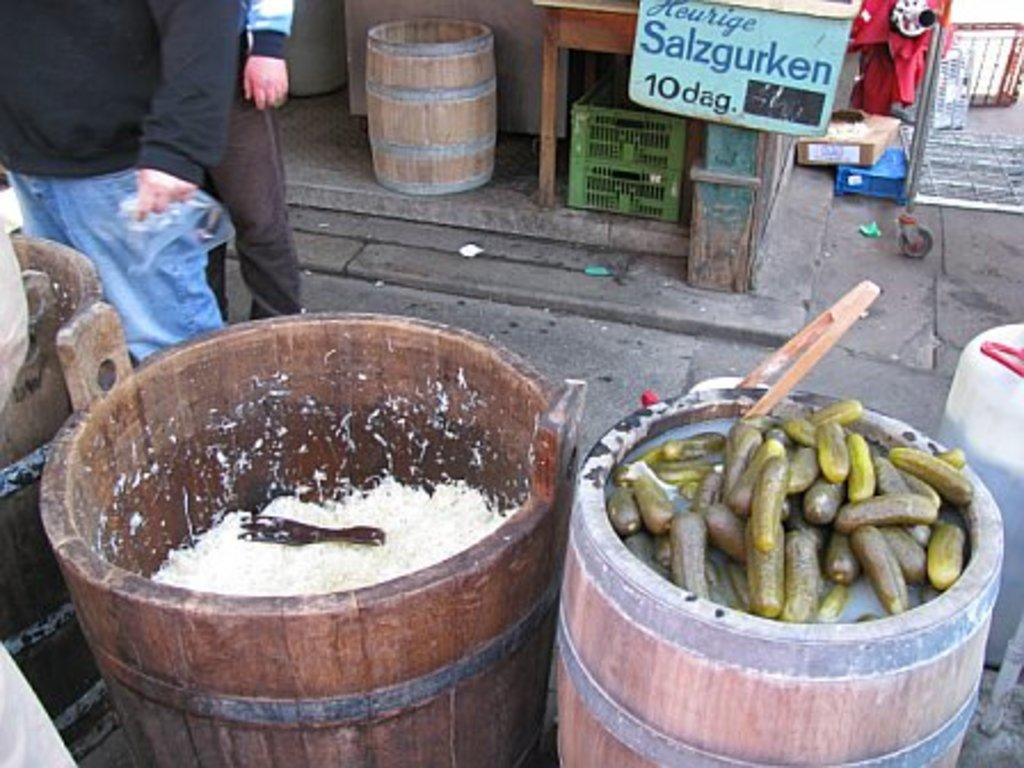What is inside the tube in the image? There are objects placed in a tube in the image. Who or what is positioned behind the tube? There are people standing behind the tube. What else can be seen in the image besides the tube and the people? There are other objects visible in the image. What type of hat is being worn by the butter in the image? There is no butter or hat present in the image. 